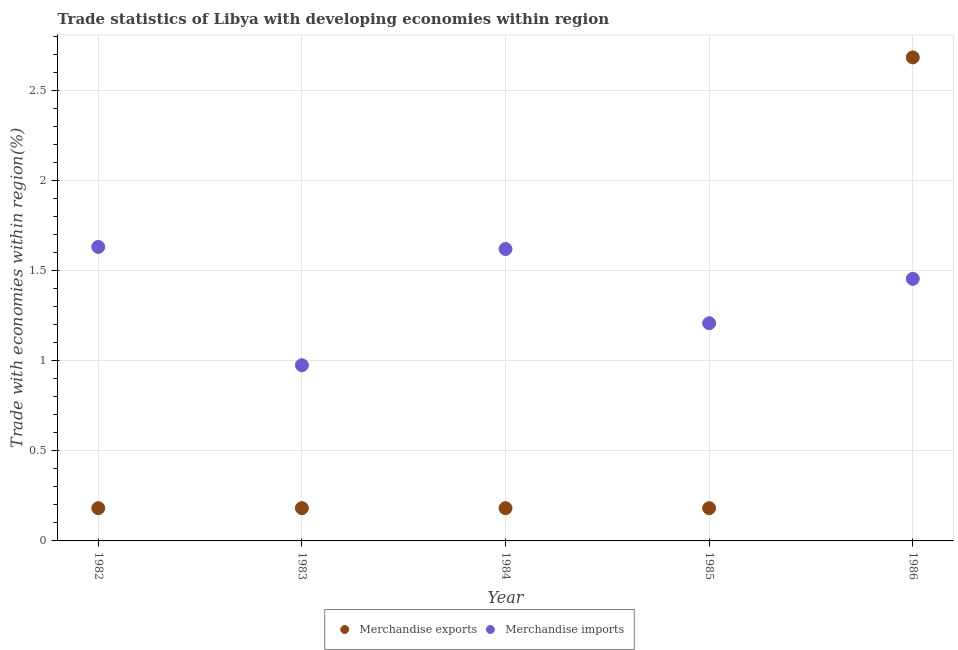How many different coloured dotlines are there?
Your answer should be compact. 2. Is the number of dotlines equal to the number of legend labels?
Give a very brief answer. Yes. What is the merchandise exports in 1984?
Provide a short and direct response. 0.18. Across all years, what is the maximum merchandise exports?
Your response must be concise. 2.68. Across all years, what is the minimum merchandise imports?
Make the answer very short. 0.97. In which year was the merchandise imports maximum?
Your answer should be compact. 1982. In which year was the merchandise imports minimum?
Offer a very short reply. 1983. What is the total merchandise imports in the graph?
Ensure brevity in your answer.  6.89. What is the difference between the merchandise exports in 1985 and that in 1986?
Your answer should be compact. -2.5. What is the difference between the merchandise imports in 1982 and the merchandise exports in 1984?
Offer a terse response. 1.45. What is the average merchandise imports per year?
Your answer should be compact. 1.38. In the year 1983, what is the difference between the merchandise imports and merchandise exports?
Keep it short and to the point. 0.79. What is the ratio of the merchandise exports in 1982 to that in 1986?
Your answer should be compact. 0.07. Is the merchandise imports in 1985 less than that in 1986?
Offer a very short reply. Yes. What is the difference between the highest and the second highest merchandise exports?
Your answer should be very brief. 2.5. What is the difference between the highest and the lowest merchandise imports?
Your answer should be compact. 0.66. In how many years, is the merchandise exports greater than the average merchandise exports taken over all years?
Make the answer very short. 1. Is the sum of the merchandise exports in 1982 and 1984 greater than the maximum merchandise imports across all years?
Provide a short and direct response. No. Does the merchandise imports monotonically increase over the years?
Your response must be concise. No. Is the merchandise exports strictly greater than the merchandise imports over the years?
Give a very brief answer. No. Is the merchandise imports strictly less than the merchandise exports over the years?
Offer a very short reply. No. How many years are there in the graph?
Provide a short and direct response. 5. Are the values on the major ticks of Y-axis written in scientific E-notation?
Provide a succinct answer. No. Where does the legend appear in the graph?
Provide a short and direct response. Bottom center. How many legend labels are there?
Ensure brevity in your answer.  2. What is the title of the graph?
Offer a terse response. Trade statistics of Libya with developing economies within region. What is the label or title of the X-axis?
Keep it short and to the point. Year. What is the label or title of the Y-axis?
Ensure brevity in your answer.  Trade with economies within region(%). What is the Trade with economies within region(%) in Merchandise exports in 1982?
Give a very brief answer. 0.18. What is the Trade with economies within region(%) in Merchandise imports in 1982?
Provide a short and direct response. 1.63. What is the Trade with economies within region(%) of Merchandise exports in 1983?
Make the answer very short. 0.18. What is the Trade with economies within region(%) of Merchandise imports in 1983?
Keep it short and to the point. 0.97. What is the Trade with economies within region(%) of Merchandise exports in 1984?
Your answer should be very brief. 0.18. What is the Trade with economies within region(%) of Merchandise imports in 1984?
Your answer should be very brief. 1.62. What is the Trade with economies within region(%) of Merchandise exports in 1985?
Make the answer very short. 0.18. What is the Trade with economies within region(%) in Merchandise imports in 1985?
Provide a succinct answer. 1.21. What is the Trade with economies within region(%) of Merchandise exports in 1986?
Make the answer very short. 2.68. What is the Trade with economies within region(%) in Merchandise imports in 1986?
Ensure brevity in your answer.  1.45. Across all years, what is the maximum Trade with economies within region(%) of Merchandise exports?
Your answer should be very brief. 2.68. Across all years, what is the maximum Trade with economies within region(%) of Merchandise imports?
Make the answer very short. 1.63. Across all years, what is the minimum Trade with economies within region(%) of Merchandise exports?
Offer a terse response. 0.18. Across all years, what is the minimum Trade with economies within region(%) in Merchandise imports?
Ensure brevity in your answer.  0.97. What is the total Trade with economies within region(%) in Merchandise exports in the graph?
Provide a short and direct response. 3.41. What is the total Trade with economies within region(%) of Merchandise imports in the graph?
Make the answer very short. 6.89. What is the difference between the Trade with economies within region(%) in Merchandise imports in 1982 and that in 1983?
Give a very brief answer. 0.66. What is the difference between the Trade with economies within region(%) in Merchandise imports in 1982 and that in 1984?
Provide a succinct answer. 0.01. What is the difference between the Trade with economies within region(%) in Merchandise exports in 1982 and that in 1985?
Offer a very short reply. 0. What is the difference between the Trade with economies within region(%) in Merchandise imports in 1982 and that in 1985?
Offer a very short reply. 0.42. What is the difference between the Trade with economies within region(%) of Merchandise exports in 1982 and that in 1986?
Give a very brief answer. -2.5. What is the difference between the Trade with economies within region(%) in Merchandise imports in 1982 and that in 1986?
Provide a short and direct response. 0.18. What is the difference between the Trade with economies within region(%) in Merchandise exports in 1983 and that in 1984?
Offer a very short reply. -0. What is the difference between the Trade with economies within region(%) of Merchandise imports in 1983 and that in 1984?
Offer a very short reply. -0.64. What is the difference between the Trade with economies within region(%) of Merchandise imports in 1983 and that in 1985?
Your response must be concise. -0.23. What is the difference between the Trade with economies within region(%) of Merchandise exports in 1983 and that in 1986?
Your answer should be very brief. -2.5. What is the difference between the Trade with economies within region(%) in Merchandise imports in 1983 and that in 1986?
Provide a succinct answer. -0.48. What is the difference between the Trade with economies within region(%) in Merchandise imports in 1984 and that in 1985?
Offer a terse response. 0.41. What is the difference between the Trade with economies within region(%) of Merchandise exports in 1984 and that in 1986?
Provide a short and direct response. -2.5. What is the difference between the Trade with economies within region(%) in Merchandise imports in 1984 and that in 1986?
Your answer should be very brief. 0.17. What is the difference between the Trade with economies within region(%) in Merchandise exports in 1985 and that in 1986?
Offer a very short reply. -2.5. What is the difference between the Trade with economies within region(%) in Merchandise imports in 1985 and that in 1986?
Make the answer very short. -0.25. What is the difference between the Trade with economies within region(%) of Merchandise exports in 1982 and the Trade with economies within region(%) of Merchandise imports in 1983?
Ensure brevity in your answer.  -0.79. What is the difference between the Trade with economies within region(%) in Merchandise exports in 1982 and the Trade with economies within region(%) in Merchandise imports in 1984?
Provide a succinct answer. -1.44. What is the difference between the Trade with economies within region(%) of Merchandise exports in 1982 and the Trade with economies within region(%) of Merchandise imports in 1985?
Keep it short and to the point. -1.03. What is the difference between the Trade with economies within region(%) in Merchandise exports in 1982 and the Trade with economies within region(%) in Merchandise imports in 1986?
Make the answer very short. -1.27. What is the difference between the Trade with economies within region(%) in Merchandise exports in 1983 and the Trade with economies within region(%) in Merchandise imports in 1984?
Provide a succinct answer. -1.44. What is the difference between the Trade with economies within region(%) in Merchandise exports in 1983 and the Trade with economies within region(%) in Merchandise imports in 1985?
Give a very brief answer. -1.03. What is the difference between the Trade with economies within region(%) in Merchandise exports in 1983 and the Trade with economies within region(%) in Merchandise imports in 1986?
Offer a very short reply. -1.27. What is the difference between the Trade with economies within region(%) in Merchandise exports in 1984 and the Trade with economies within region(%) in Merchandise imports in 1985?
Give a very brief answer. -1.03. What is the difference between the Trade with economies within region(%) of Merchandise exports in 1984 and the Trade with economies within region(%) of Merchandise imports in 1986?
Provide a succinct answer. -1.27. What is the difference between the Trade with economies within region(%) in Merchandise exports in 1985 and the Trade with economies within region(%) in Merchandise imports in 1986?
Keep it short and to the point. -1.27. What is the average Trade with economies within region(%) of Merchandise exports per year?
Offer a terse response. 0.68. What is the average Trade with economies within region(%) in Merchandise imports per year?
Your answer should be very brief. 1.38. In the year 1982, what is the difference between the Trade with economies within region(%) in Merchandise exports and Trade with economies within region(%) in Merchandise imports?
Keep it short and to the point. -1.45. In the year 1983, what is the difference between the Trade with economies within region(%) in Merchandise exports and Trade with economies within region(%) in Merchandise imports?
Give a very brief answer. -0.79. In the year 1984, what is the difference between the Trade with economies within region(%) of Merchandise exports and Trade with economies within region(%) of Merchandise imports?
Ensure brevity in your answer.  -1.44. In the year 1985, what is the difference between the Trade with economies within region(%) of Merchandise exports and Trade with economies within region(%) of Merchandise imports?
Offer a terse response. -1.03. In the year 1986, what is the difference between the Trade with economies within region(%) in Merchandise exports and Trade with economies within region(%) in Merchandise imports?
Provide a short and direct response. 1.23. What is the ratio of the Trade with economies within region(%) of Merchandise exports in 1982 to that in 1983?
Keep it short and to the point. 1. What is the ratio of the Trade with economies within region(%) of Merchandise imports in 1982 to that in 1983?
Give a very brief answer. 1.67. What is the ratio of the Trade with economies within region(%) of Merchandise exports in 1982 to that in 1984?
Keep it short and to the point. 1. What is the ratio of the Trade with economies within region(%) of Merchandise imports in 1982 to that in 1984?
Provide a succinct answer. 1.01. What is the ratio of the Trade with economies within region(%) in Merchandise exports in 1982 to that in 1985?
Your answer should be compact. 1. What is the ratio of the Trade with economies within region(%) in Merchandise imports in 1982 to that in 1985?
Provide a short and direct response. 1.35. What is the ratio of the Trade with economies within region(%) in Merchandise exports in 1982 to that in 1986?
Make the answer very short. 0.07. What is the ratio of the Trade with economies within region(%) in Merchandise imports in 1982 to that in 1986?
Provide a succinct answer. 1.12. What is the ratio of the Trade with economies within region(%) in Merchandise imports in 1983 to that in 1984?
Give a very brief answer. 0.6. What is the ratio of the Trade with economies within region(%) of Merchandise exports in 1983 to that in 1985?
Provide a succinct answer. 1. What is the ratio of the Trade with economies within region(%) of Merchandise imports in 1983 to that in 1985?
Your answer should be very brief. 0.81. What is the ratio of the Trade with economies within region(%) in Merchandise exports in 1983 to that in 1986?
Keep it short and to the point. 0.07. What is the ratio of the Trade with economies within region(%) in Merchandise imports in 1983 to that in 1986?
Provide a succinct answer. 0.67. What is the ratio of the Trade with economies within region(%) of Merchandise imports in 1984 to that in 1985?
Provide a succinct answer. 1.34. What is the ratio of the Trade with economies within region(%) in Merchandise exports in 1984 to that in 1986?
Ensure brevity in your answer.  0.07. What is the ratio of the Trade with economies within region(%) of Merchandise imports in 1984 to that in 1986?
Ensure brevity in your answer.  1.11. What is the ratio of the Trade with economies within region(%) of Merchandise exports in 1985 to that in 1986?
Provide a succinct answer. 0.07. What is the ratio of the Trade with economies within region(%) in Merchandise imports in 1985 to that in 1986?
Offer a terse response. 0.83. What is the difference between the highest and the second highest Trade with economies within region(%) of Merchandise exports?
Give a very brief answer. 2.5. What is the difference between the highest and the second highest Trade with economies within region(%) in Merchandise imports?
Provide a succinct answer. 0.01. What is the difference between the highest and the lowest Trade with economies within region(%) in Merchandise exports?
Your answer should be very brief. 2.5. What is the difference between the highest and the lowest Trade with economies within region(%) in Merchandise imports?
Provide a short and direct response. 0.66. 